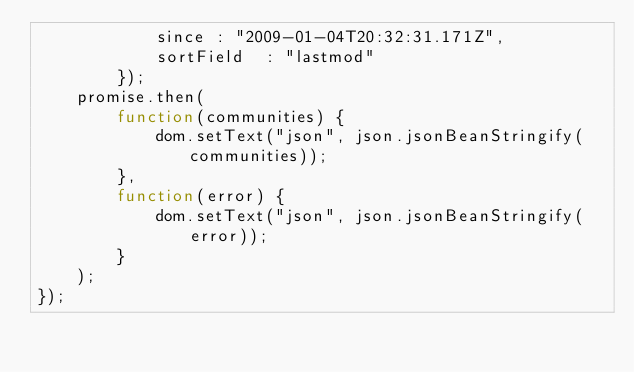<code> <loc_0><loc_0><loc_500><loc_500><_JavaScript_>            since : "2009-01-04T20:32:31.171Z",
            sortField  : "lastmod"
        });
    promise.then(
        function(communities) {
            dom.setText("json", json.jsonBeanStringify(communities));
        },
        function(error) {
            dom.setText("json", json.jsonBeanStringify(error));
        }
    );
});
</code> 